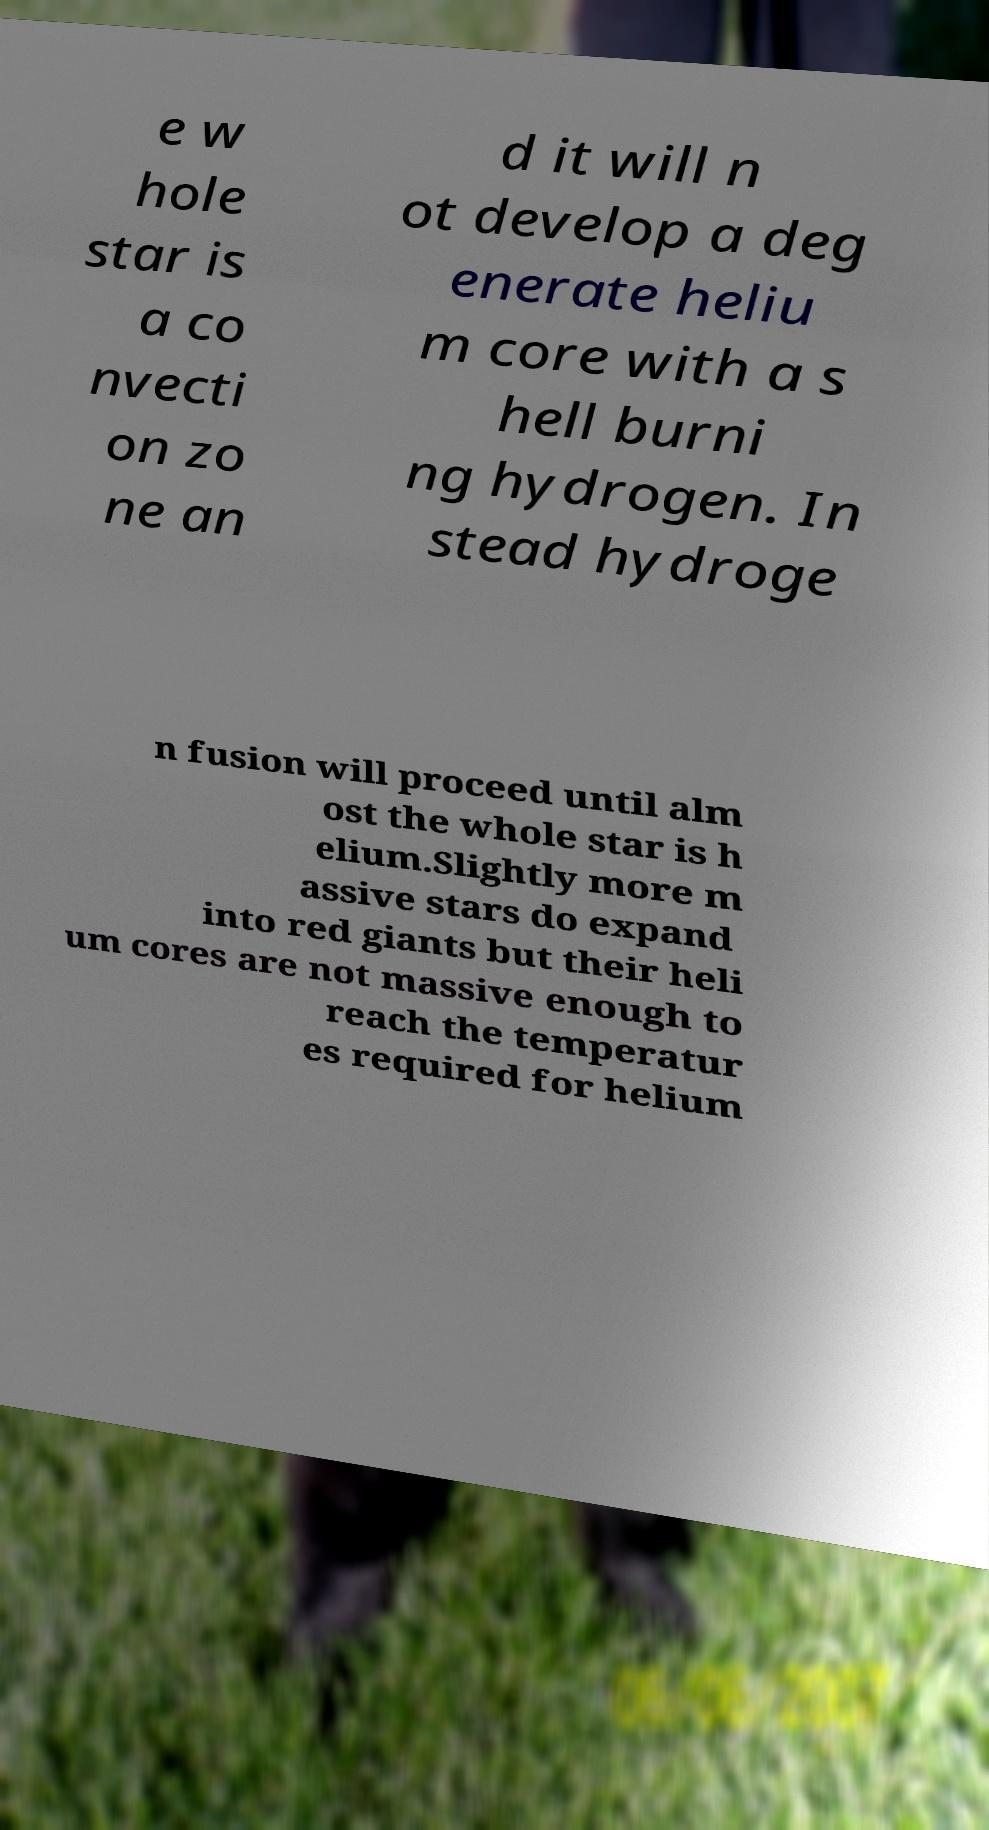I need the written content from this picture converted into text. Can you do that? e w hole star is a co nvecti on zo ne an d it will n ot develop a deg enerate heliu m core with a s hell burni ng hydrogen. In stead hydroge n fusion will proceed until alm ost the whole star is h elium.Slightly more m assive stars do expand into red giants but their heli um cores are not massive enough to reach the temperatur es required for helium 